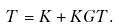<formula> <loc_0><loc_0><loc_500><loc_500>T = K + K G T .</formula> 